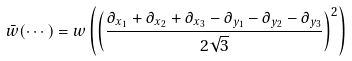Convert formula to latex. <formula><loc_0><loc_0><loc_500><loc_500>\bar { w } ( \cdots ) = w \left ( \left ( \frac { \partial _ { x _ { 1 } } + \partial _ { x _ { 2 } } + \partial _ { x _ { 3 } } - \partial _ { y _ { 1 } } - \partial _ { y _ { 2 } } - \partial _ { y _ { 3 } } } { 2 \sqrt { 3 } } \right ) ^ { 2 } \right )</formula> 